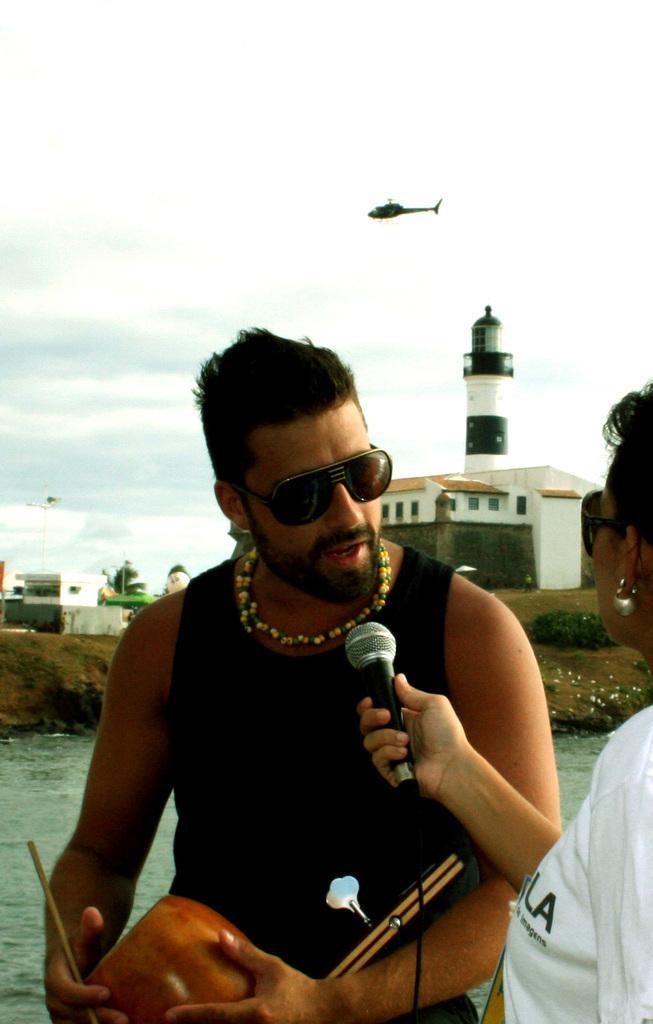Describe this image in one or two sentences. In this image we can see persons standing and one of them is holding mic in the hands. In the background we can see water, grass, flowers, building, light house, helicopter in the air, sky with clouds, poles and buildings. 